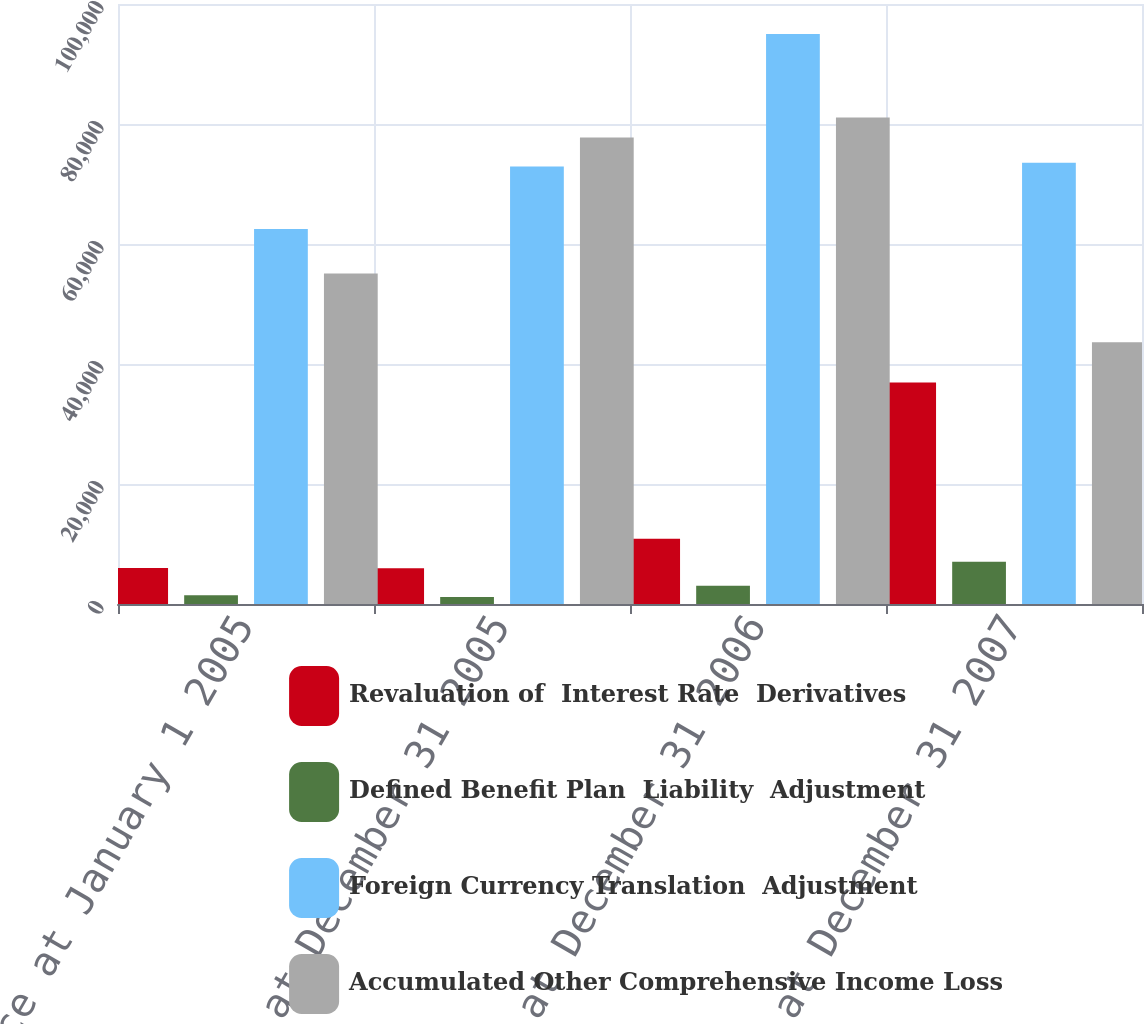Convert chart. <chart><loc_0><loc_0><loc_500><loc_500><stacked_bar_chart><ecel><fcel>Balance at January 1 2005<fcel>Balance at December 31 2005<fcel>Balance at December 31 2006<fcel>Balance at December 31 2007<nl><fcel>Revaluation of  Interest Rate  Derivatives<fcel>5986<fcel>5970<fcel>10859<fcel>36937<nl><fcel>Defined Benefit Plan  Liability  Adjustment<fcel>1447<fcel>1150<fcel>3044<fcel>7026<nl><fcel>Foreign Currency Translation  Adjustment<fcel>62511<fcel>72922<fcel>94987<fcel>73555<nl><fcel>Accumulated Other Comprehensive Income Loss<fcel>55078<fcel>77742<fcel>81084<fcel>43644<nl></chart> 